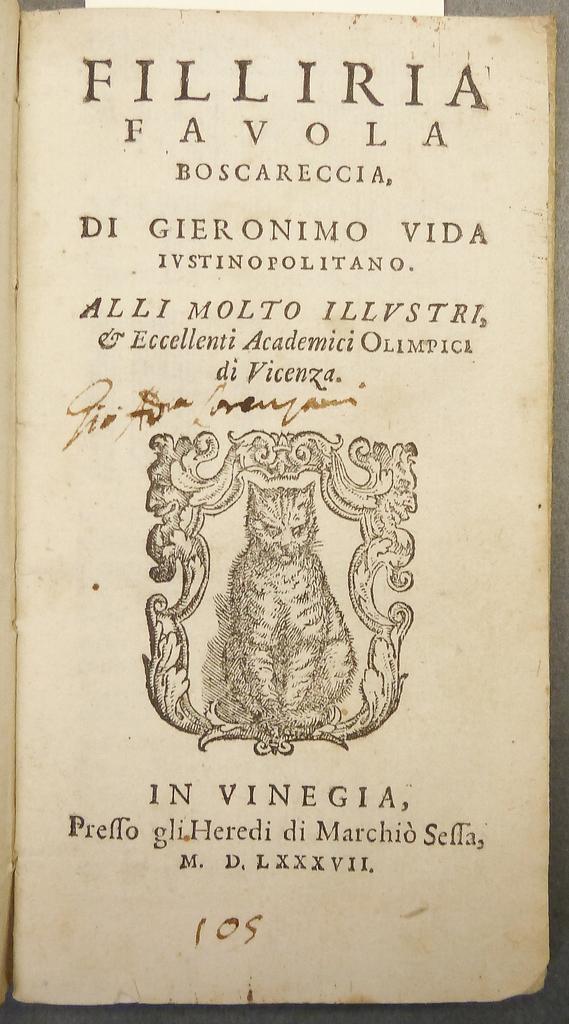What is the first word on top?
Make the answer very short. Filliria. 